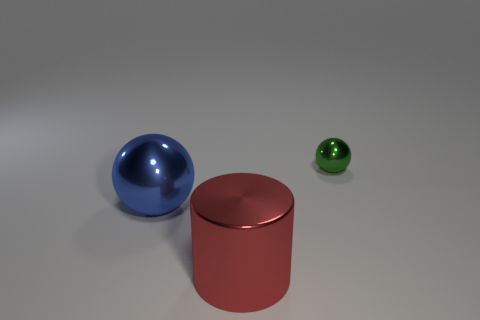What size is the shiny sphere right of the metal thing that is in front of the sphere on the left side of the green object?
Offer a very short reply. Small. The green metallic thing that is the same shape as the big blue object is what size?
Give a very brief answer. Small. Is the size of the green metallic sphere the same as the sphere that is to the left of the red shiny object?
Offer a very short reply. No. Is there any other thing that has the same size as the green ball?
Provide a succinct answer. No. How many other objects are the same shape as the red object?
Ensure brevity in your answer.  0. Is the green metal ball the same size as the red cylinder?
Your answer should be compact. No. Are any big yellow objects visible?
Provide a short and direct response. No. Are there any blue balls that have the same material as the tiny green thing?
Provide a succinct answer. Yes. How many other objects have the same shape as the blue object?
Ensure brevity in your answer.  1. There is another green ball that is made of the same material as the big ball; what size is it?
Your answer should be very brief. Small. 